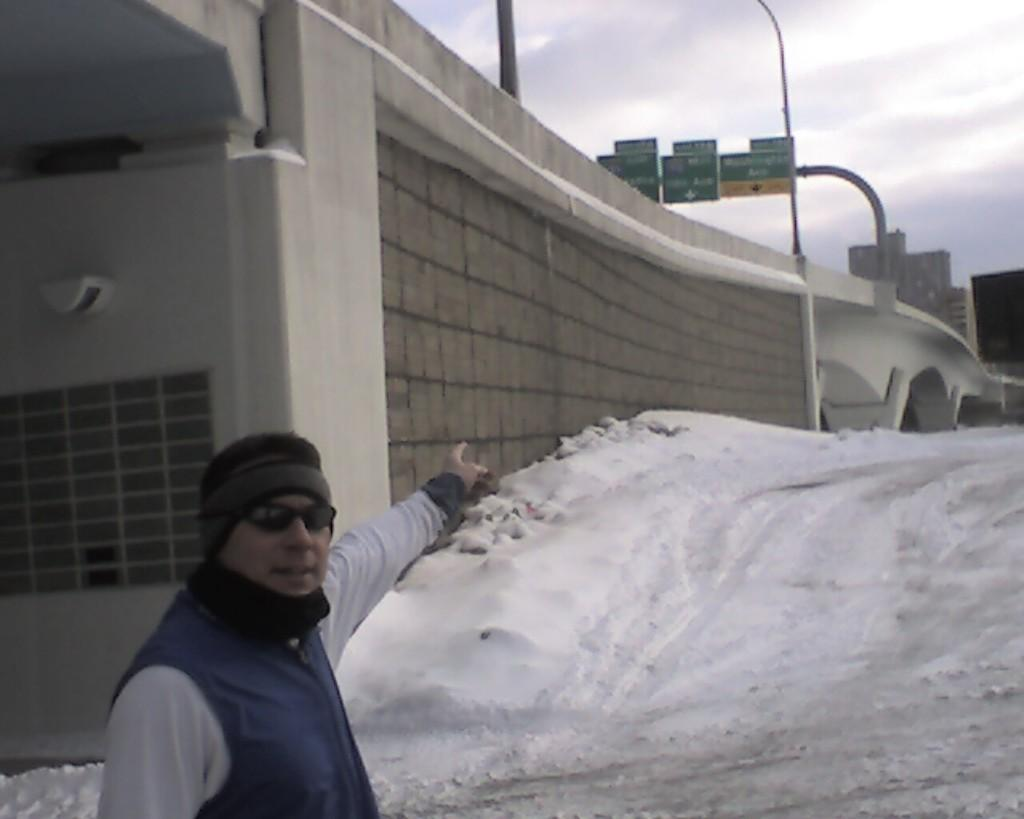What is the main subject of the image? There is a person in the image. Can you describe the person's clothing? The person is wearing a white dress and a blue jacket. What is the person's posture in the image? The person is standing. What can be seen in the background of the image? There is a bridge, boards, snow, buildings, and the sky visible in the background of the image. What type of trade is being conducted on the bridge in the image? There is no indication of any trade being conducted in the image; it simply shows a person standing with a bridge, boards, snow, buildings, and the sky in the background. How many beds are visible in the image? There are no beds present in the image. 